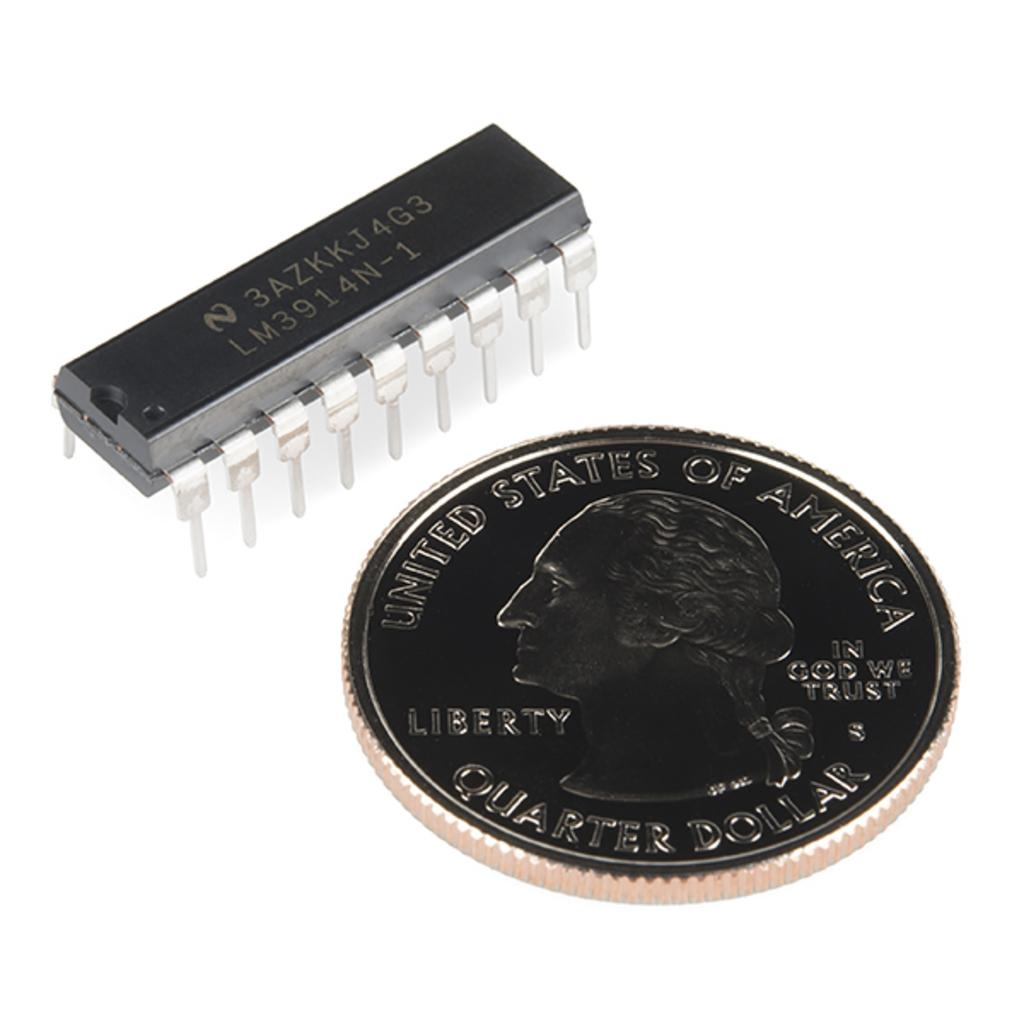Provide a one-sentence caption for the provided image. A quarter dollar and a small black device sit on a light table. 